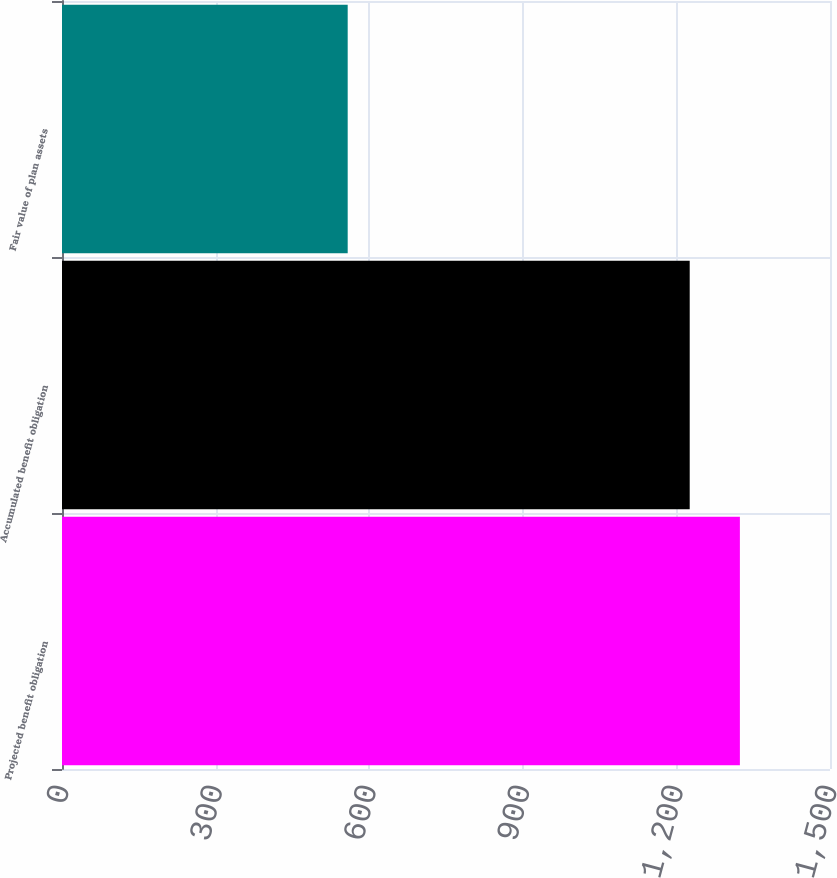Convert chart to OTSL. <chart><loc_0><loc_0><loc_500><loc_500><bar_chart><fcel>Projected benefit obligation<fcel>Accumulated benefit obligation<fcel>Fair value of plan assets<nl><fcel>1324<fcel>1226<fcel>558<nl></chart> 